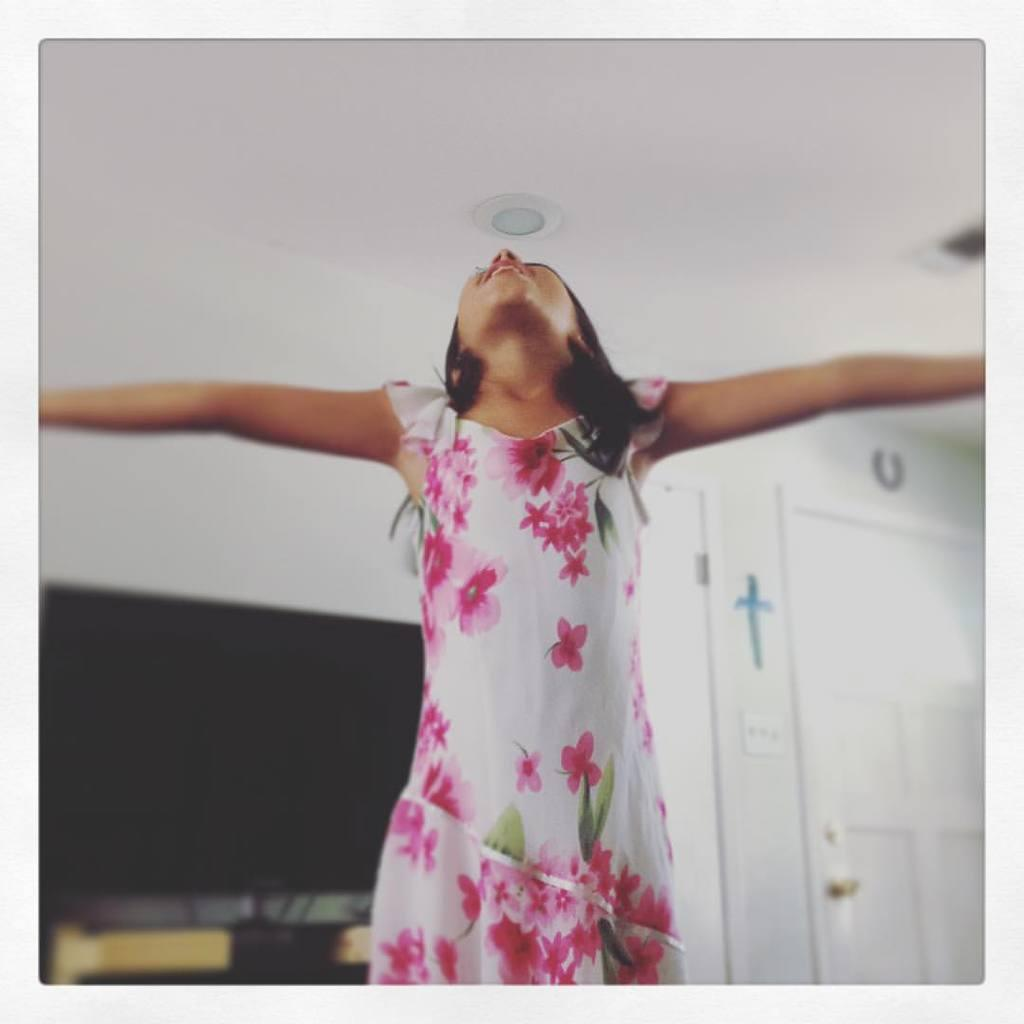Who is the main subject in the image? There is a girl in the image. What is the girl doing in the image? The girl is standing and appears to be dancing. What objects can be seen in the image besides the girl? There is a television and a door in the image. Can you describe the background of the image? The background of the image is slightly blurred. How many goldfish are swimming in the cup in the image? There are no goldfish or cups present in the image. 